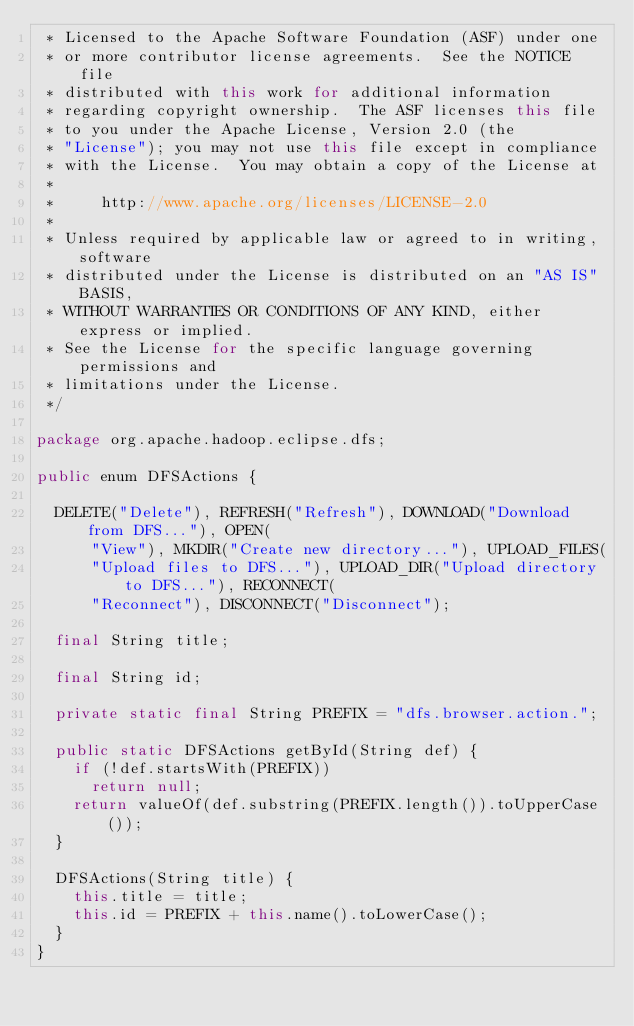Convert code to text. <code><loc_0><loc_0><loc_500><loc_500><_Java_> * Licensed to the Apache Software Foundation (ASF) under one
 * or more contributor license agreements.  See the NOTICE file
 * distributed with this work for additional information
 * regarding copyright ownership.  The ASF licenses this file
 * to you under the Apache License, Version 2.0 (the
 * "License"); you may not use this file except in compliance
 * with the License.  You may obtain a copy of the License at
 *
 *     http://www.apache.org/licenses/LICENSE-2.0
 *
 * Unless required by applicable law or agreed to in writing, software
 * distributed under the License is distributed on an "AS IS" BASIS,
 * WITHOUT WARRANTIES OR CONDITIONS OF ANY KIND, either express or implied.
 * See the License for the specific language governing permissions and
 * limitations under the License.
 */

package org.apache.hadoop.eclipse.dfs;

public enum DFSActions {

  DELETE("Delete"), REFRESH("Refresh"), DOWNLOAD("Download from DFS..."), OPEN(
      "View"), MKDIR("Create new directory..."), UPLOAD_FILES(
      "Upload files to DFS..."), UPLOAD_DIR("Upload directory to DFS..."), RECONNECT(
      "Reconnect"), DISCONNECT("Disconnect");

  final String title;

  final String id;

  private static final String PREFIX = "dfs.browser.action.";

  public static DFSActions getById(String def) {
    if (!def.startsWith(PREFIX))
      return null;
    return valueOf(def.substring(PREFIX.length()).toUpperCase());
  }

  DFSActions(String title) {
    this.title = title;
    this.id = PREFIX + this.name().toLowerCase();
  }
}
</code> 